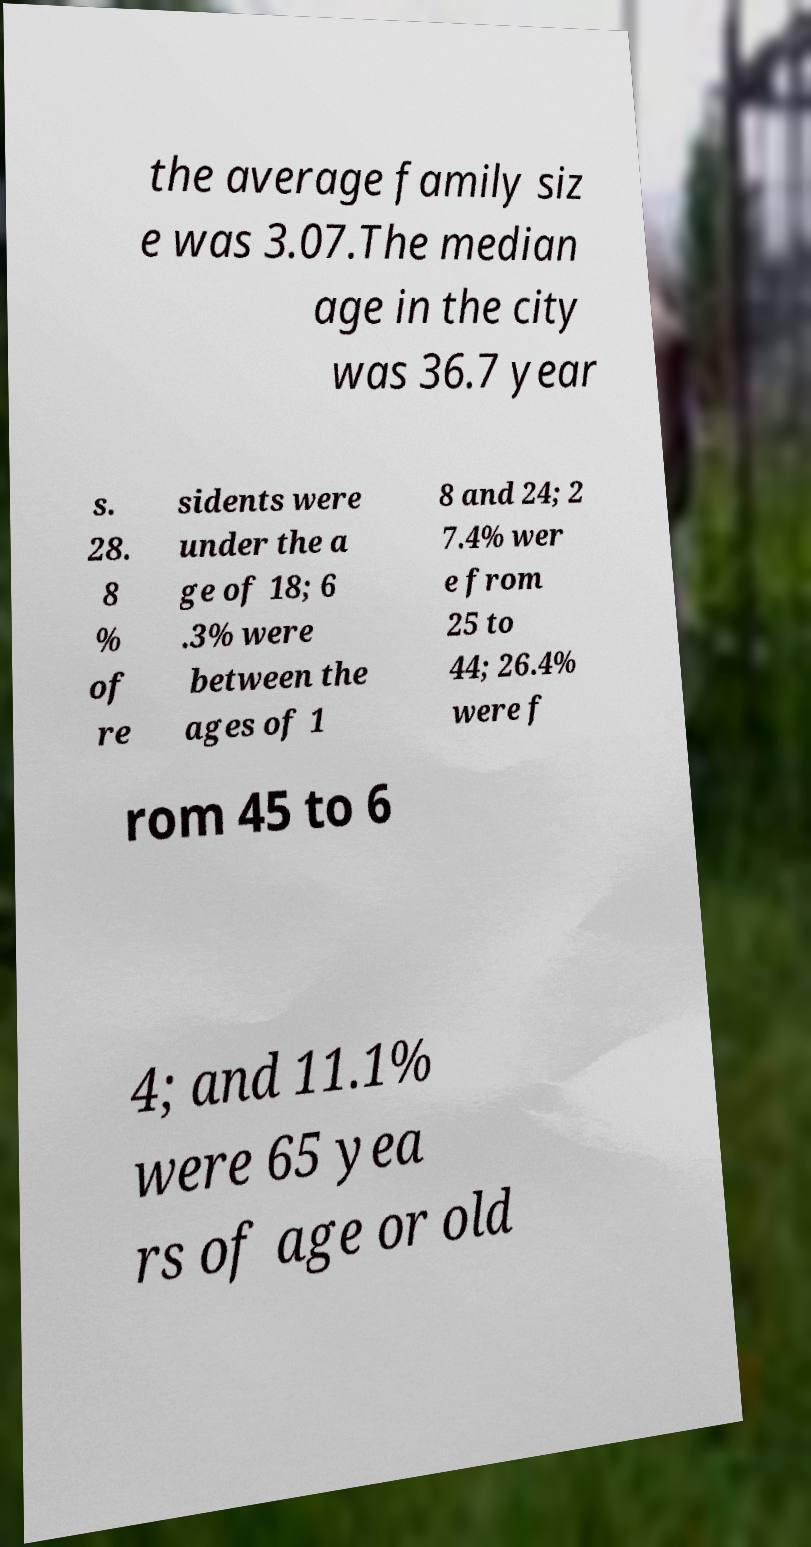For documentation purposes, I need the text within this image transcribed. Could you provide that? the average family siz e was 3.07.The median age in the city was 36.7 year s. 28. 8 % of re sidents were under the a ge of 18; 6 .3% were between the ages of 1 8 and 24; 2 7.4% wer e from 25 to 44; 26.4% were f rom 45 to 6 4; and 11.1% were 65 yea rs of age or old 